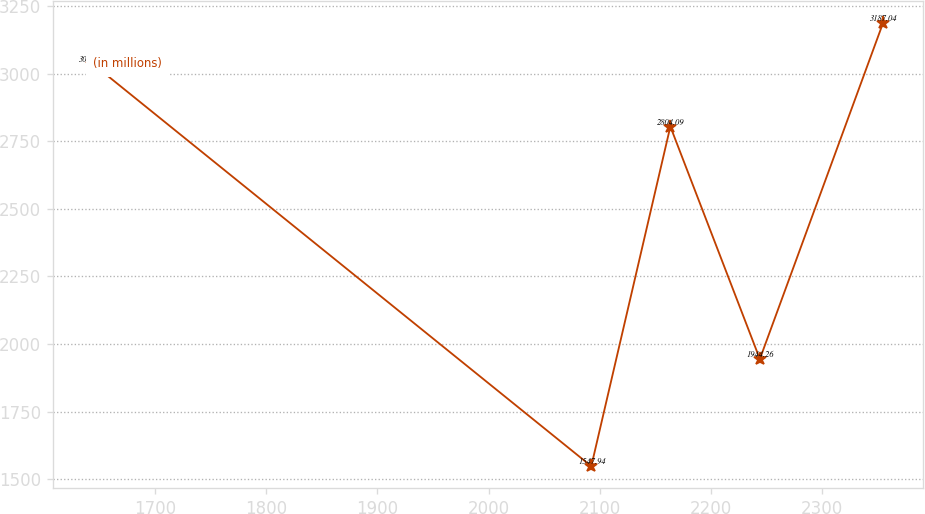<chart> <loc_0><loc_0><loc_500><loc_500><line_chart><ecel><fcel>(in millions)<nl><fcel>1643.48<fcel>3036.92<nl><fcel>2092.53<fcel>1547.94<nl><fcel>2163.7<fcel>2804.09<nl><fcel>2244.25<fcel>1944.26<nl><fcel>2355.15<fcel>3187.04<nl></chart> 